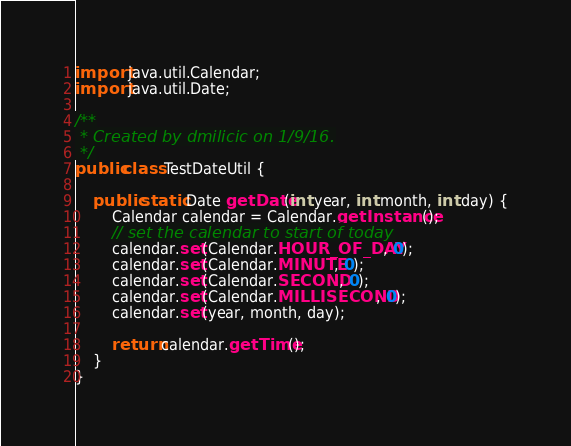Convert code to text. <code><loc_0><loc_0><loc_500><loc_500><_Java_>
import java.util.Calendar;
import java.util.Date;

/**
 * Created by dmilicic on 1/9/16.
 */
public class TestDateUtil {

    public static Date getDate(int year, int month, int day) {
        Calendar calendar = Calendar.getInstance();
        // set the calendar to start of today
        calendar.set(Calendar.HOUR_OF_DAY, 0);
        calendar.set(Calendar.MINUTE, 0);
        calendar.set(Calendar.SECOND, 0);
        calendar.set(Calendar.MILLISECOND, 0);
        calendar.set(year, month, day);

        return calendar.getTime();
    }
}
</code> 